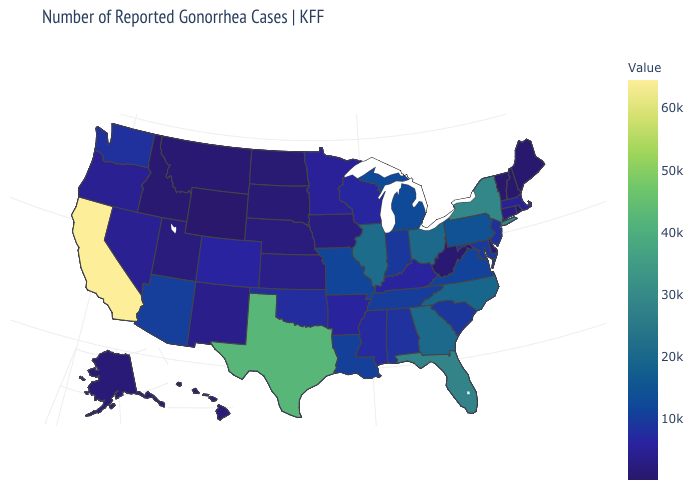Is the legend a continuous bar?
Write a very short answer. Yes. Does Massachusetts have the lowest value in the USA?
Give a very brief answer. No. Among the states that border Delaware , which have the lowest value?
Give a very brief answer. New Jersey. Among the states that border Texas , does New Mexico have the lowest value?
Short answer required. Yes. 